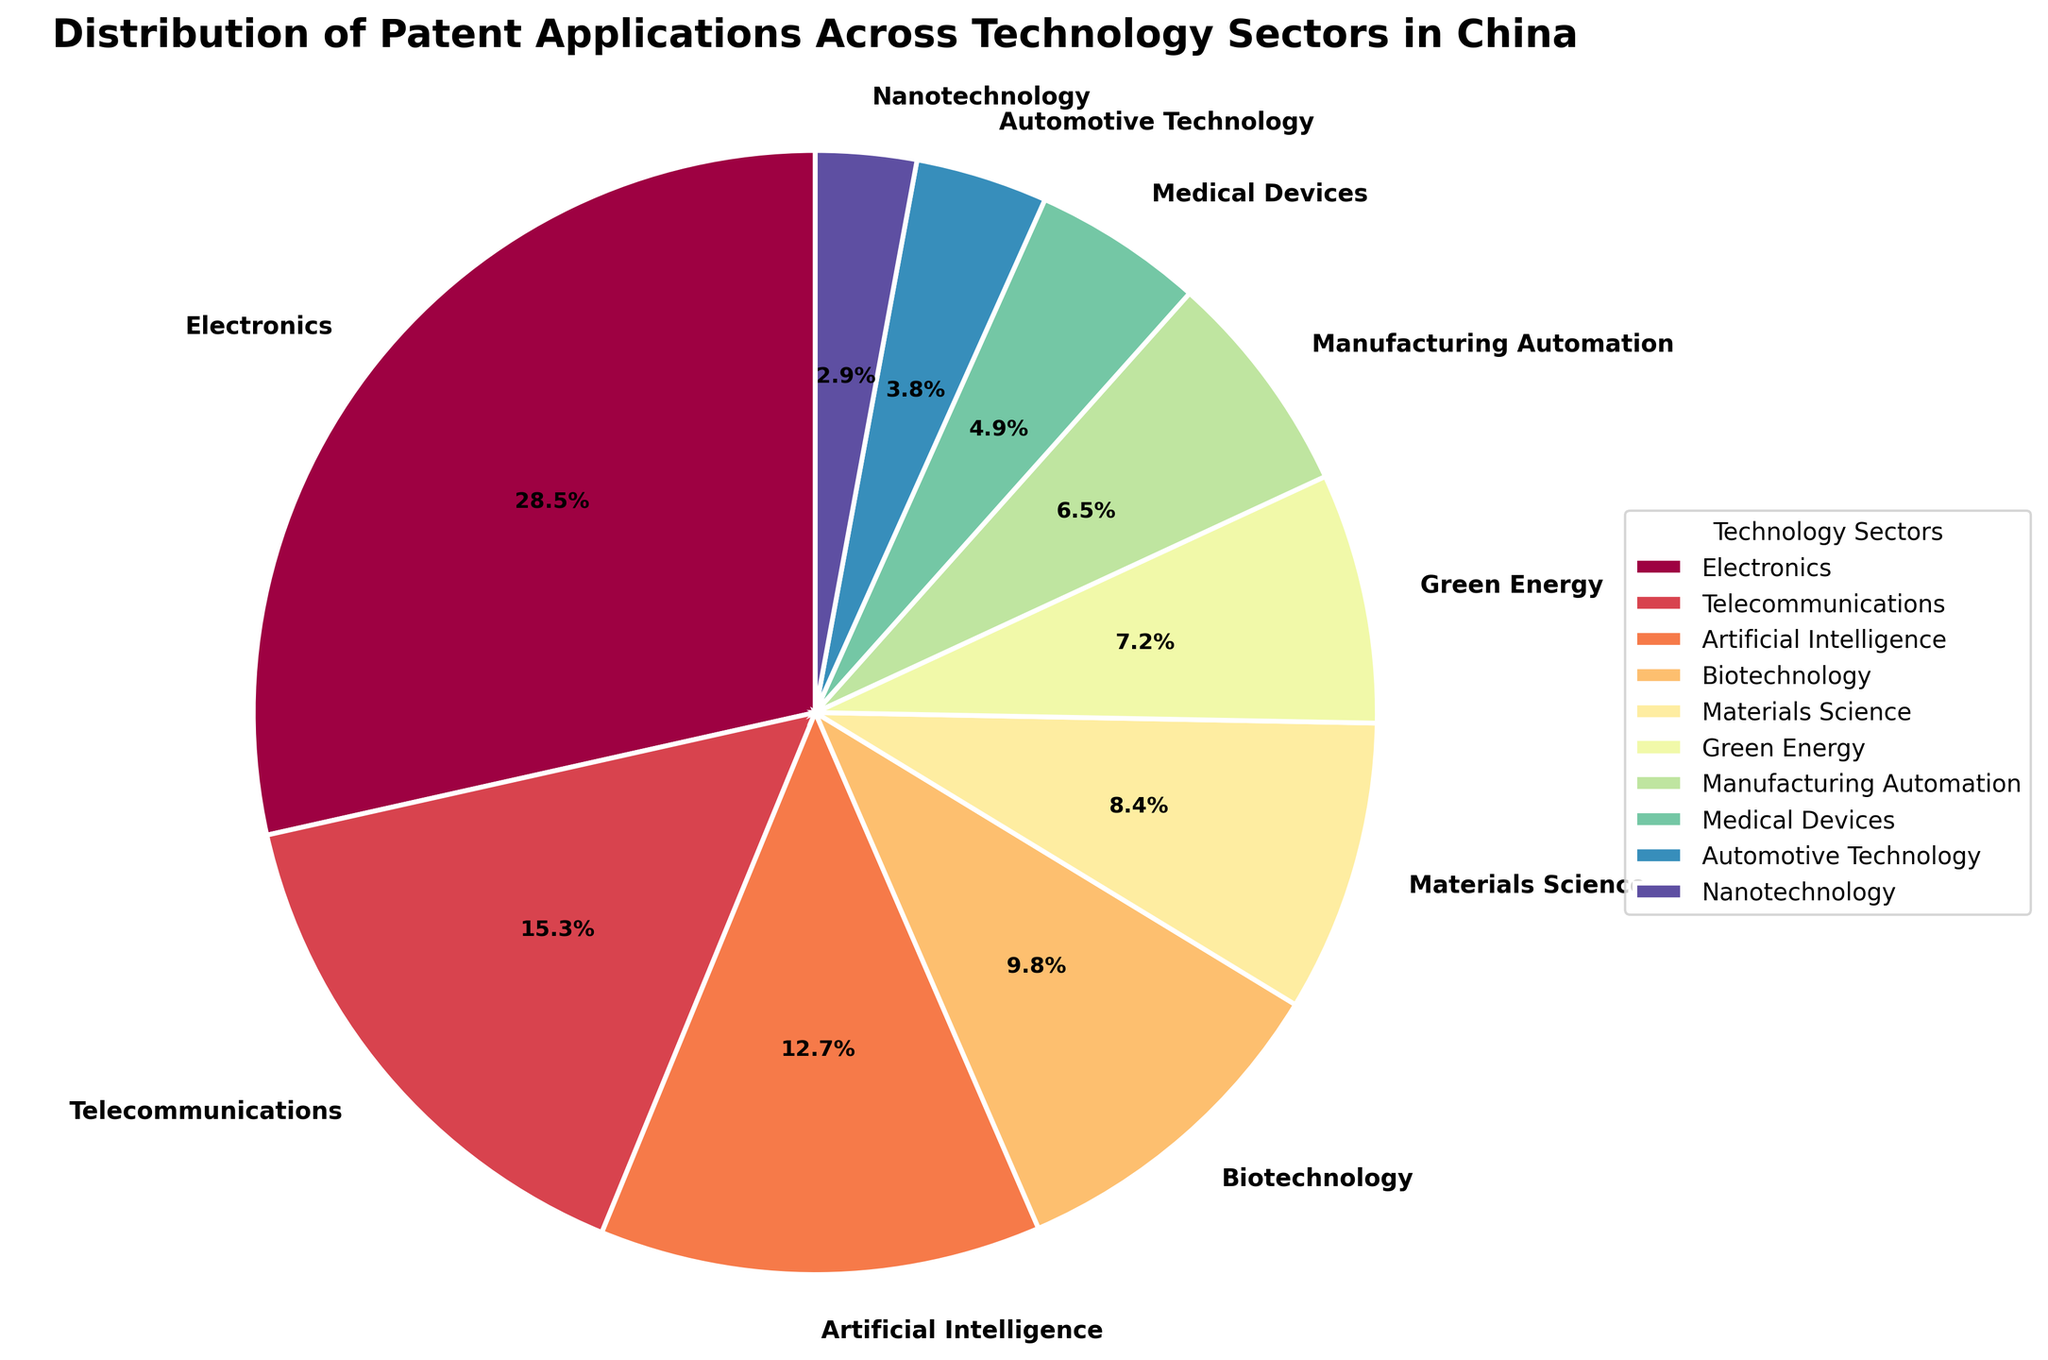What technology sector has the highest percentage of patent applications? By examining the pie chart, the sector with the largest slice should be identified. The label and percentage associated with that sector will answer the question.
Answer: Electronics with 28.5% Which two technology sectors have the closest percentages of patent applications? By comparing the sizes of the slices, look for two slices that visually appear to have almost the same area. Then, confirm by looking at their percentage labels.
Answer: Medical Devices (4.9%) and Automotive Technology (3.8%) What is the combined percentage of patent applications for Green Energy and Manufacturing Automation sectors? Identify the slices corresponding to Green Energy and Manufacturing Automation. Add their percentages together to find the combined percentage.
Answer: 7.2% + 6.5% = 13.7% How much more prevalent are Electronics patents compared to Telecommunications patents? Find the percentage for both Electronics and Telecommunications sectors, then subtract the smaller percentage (Telecommunications) from the larger one (Electronics) to get the difference.
Answer: 28.5% - 15.3% = 13.2% Which sector has the smallest percentage of patent applications, and what is that percentage? Look for the smallest slice in the pie chart and note its label and percentage.
Answer: Nanotechnology with 2.9% What is the percentage difference between the top two sectors with the highest patent applications? First, find the percentages of the top two sectors (Electronics and Telecommunications). Subtract the smaller percentage (Telecommunications) from the larger one (Electronics).
Answer: 28.5% - 15.3% = 13.2% Which sectors contribute to over half of the total patent applications, and what is their combined percentage? Adding up the percentages from the largest downwards until the sum exceeds 50%. Here, starting with Electronics, Telecommunications, Artificial Intelligence, and Biotechnology, their combined percentage exceeds half.
Answer: Electronics, Telecommunications, Artificial Intelligence, and Biotechnology contribute to a combined 66.3% What is the percentage share of the technology sectors that are not listed in the top three? Sum the percentages of all sectors except for Electronics, Telecommunications, and Artificial Intelligence, and calculate their total percentage.
Answer: 9.8% + 8.4% + 7.2% + 6.5% + 4.9% + 3.8% + 2.9% = 43.5% Is Biotechnology or Green Energy more prevalent in terms of patent applications, and by how much? Compare the percentages for Biotechnology (9.8%) and Green Energy (7.2%). Subtract the smaller percentage (Green Energy) from the larger one (Biotechnology).
Answer: Biotechnology is more prevalent by 2.6% Which sector is visually represented with a red color in the pie chart? Look for the slice that visually has the red color and take note of the associated technology sector from the legend.
Answer: Without visual, cannot determine specific color assignment 